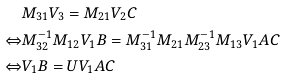<formula> <loc_0><loc_0><loc_500><loc_500>& M _ { 3 1 } V _ { 3 } = M _ { 2 1 } V _ { 2 } C \\ \Leftrightarrow & M _ { 3 2 } ^ { - 1 } M _ { 1 2 } V _ { 1 } B = M _ { 3 1 } ^ { - 1 } M _ { 2 1 } M _ { 2 3 } ^ { - 1 } M _ { 1 3 } V _ { 1 } A C \\ \Leftrightarrow & V _ { 1 } B = U V _ { 1 } A C</formula> 